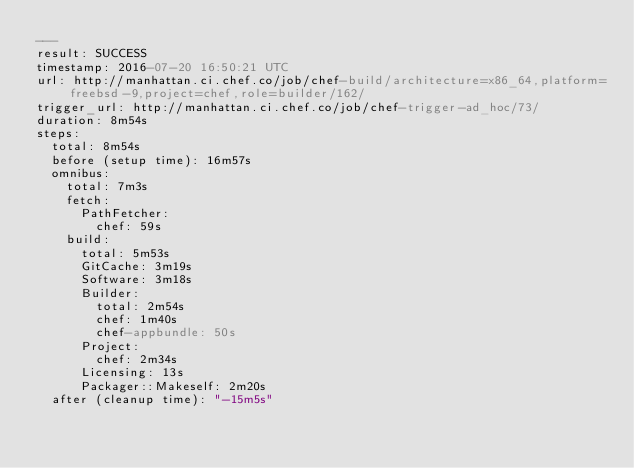Convert code to text. <code><loc_0><loc_0><loc_500><loc_500><_YAML_>---
result: SUCCESS
timestamp: 2016-07-20 16:50:21 UTC
url: http://manhattan.ci.chef.co/job/chef-build/architecture=x86_64,platform=freebsd-9,project=chef,role=builder/162/
trigger_url: http://manhattan.ci.chef.co/job/chef-trigger-ad_hoc/73/
duration: 8m54s
steps:
  total: 8m54s
  before (setup time): 16m57s
  omnibus:
    total: 7m3s
    fetch:
      PathFetcher:
        chef: 59s
    build:
      total: 5m53s
      GitCache: 3m19s
      Software: 3m18s
      Builder:
        total: 2m54s
        chef: 1m40s
        chef-appbundle: 50s
      Project:
        chef: 2m34s
      Licensing: 13s
      Packager::Makeself: 2m20s
  after (cleanup time): "-15m5s"
</code> 